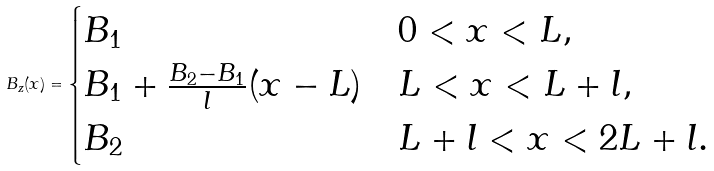Convert formula to latex. <formula><loc_0><loc_0><loc_500><loc_500>B _ { z } ( x ) = \begin{cases} B _ { 1 } & 0 < x < L , \\ B _ { 1 } + \frac { B _ { 2 } - B _ { 1 } } { l } ( x - L ) & L < x < L + l , \\ B _ { 2 } & L + l < x < 2 L + l . \end{cases}</formula> 